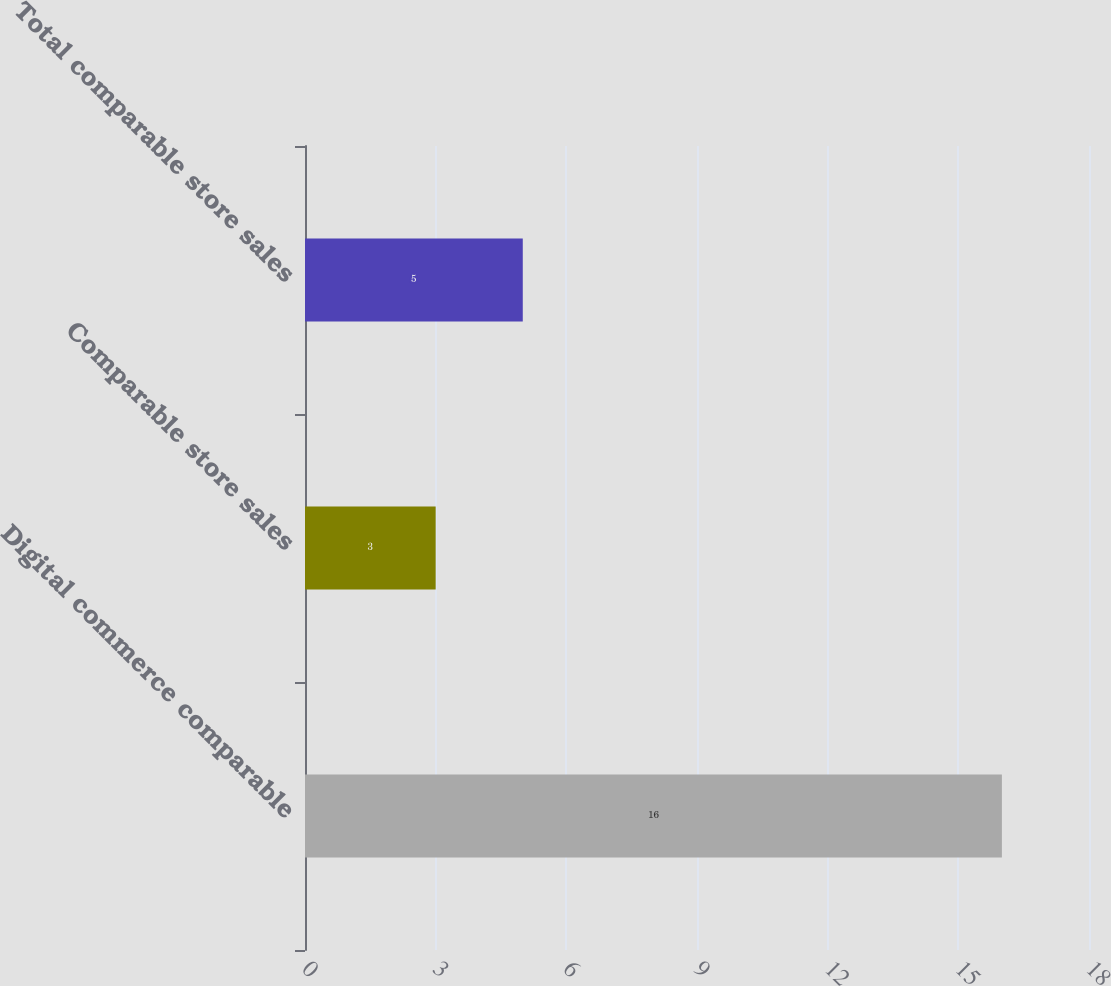Convert chart. <chart><loc_0><loc_0><loc_500><loc_500><bar_chart><fcel>Digital commerce comparable<fcel>Comparable store sales<fcel>Total comparable store sales<nl><fcel>16<fcel>3<fcel>5<nl></chart> 